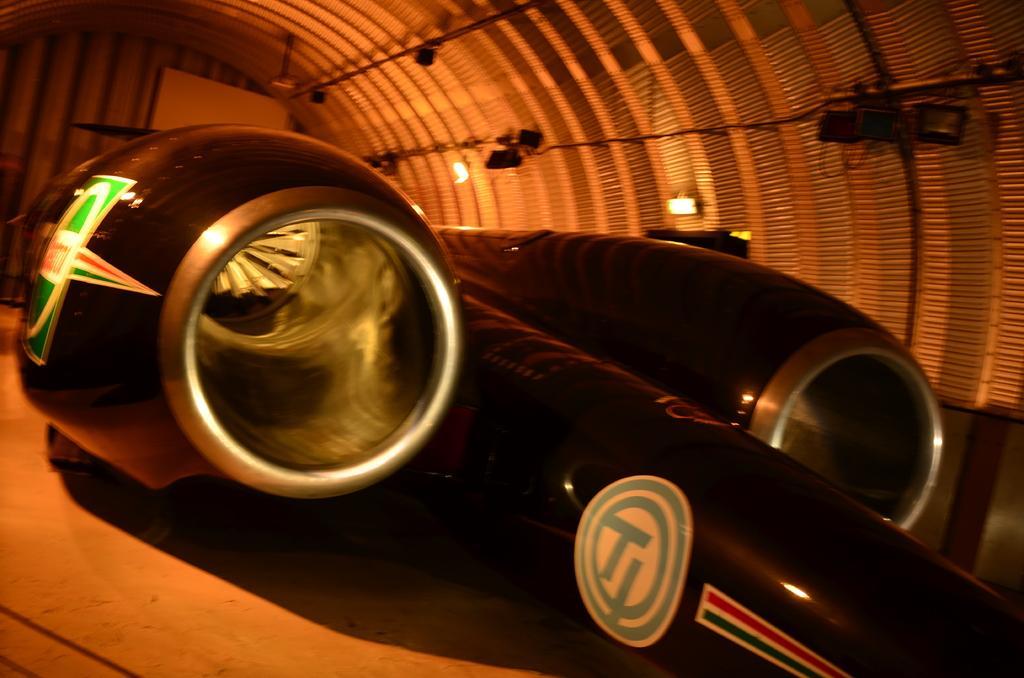Please provide a concise description of this image. In this image we can see an aircraft with logos. In the back there are lights and few other objects. 